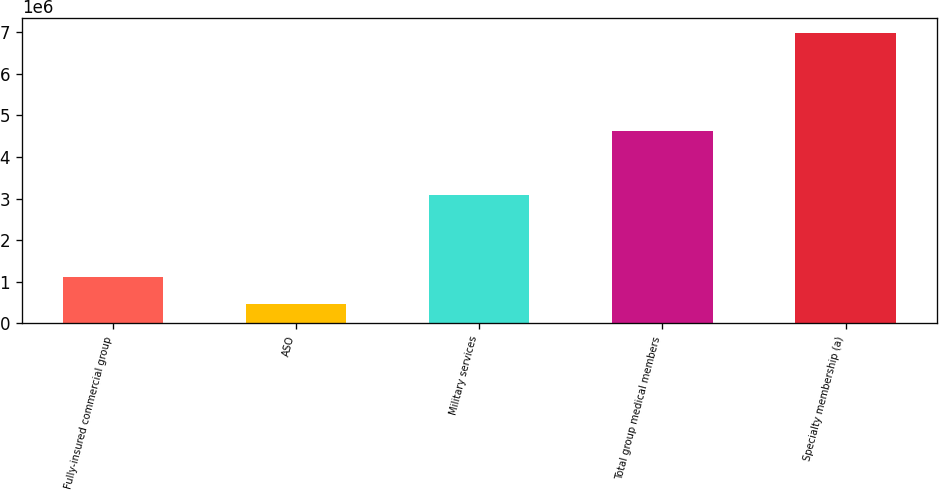<chart> <loc_0><loc_0><loc_500><loc_500><bar_chart><fcel>Fully-insured commercial group<fcel>ASO<fcel>Military services<fcel>Total group medical members<fcel>Specialty membership (a)<nl><fcel>1.11143e+06<fcel>458700<fcel>3.0818e+06<fcel>4.6382e+06<fcel>6.986e+06<nl></chart> 